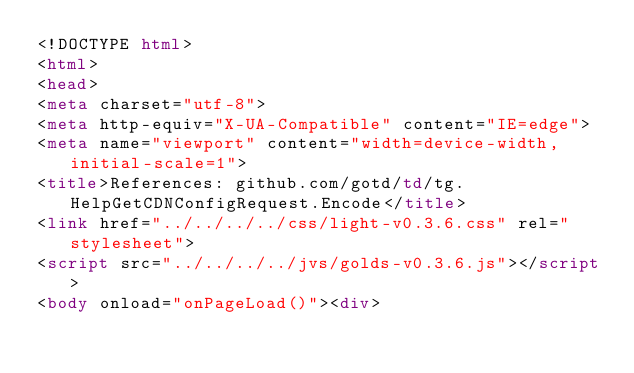<code> <loc_0><loc_0><loc_500><loc_500><_HTML_><!DOCTYPE html>
<html>
<head>
<meta charset="utf-8">
<meta http-equiv="X-UA-Compatible" content="IE=edge">
<meta name="viewport" content="width=device-width, initial-scale=1">
<title>References: github.com/gotd/td/tg.HelpGetCDNConfigRequest.Encode</title>
<link href="../../../../css/light-v0.3.6.css" rel="stylesheet">
<script src="../../../../jvs/golds-v0.3.6.js"></script>
<body onload="onPageLoad()"><div>
</code> 